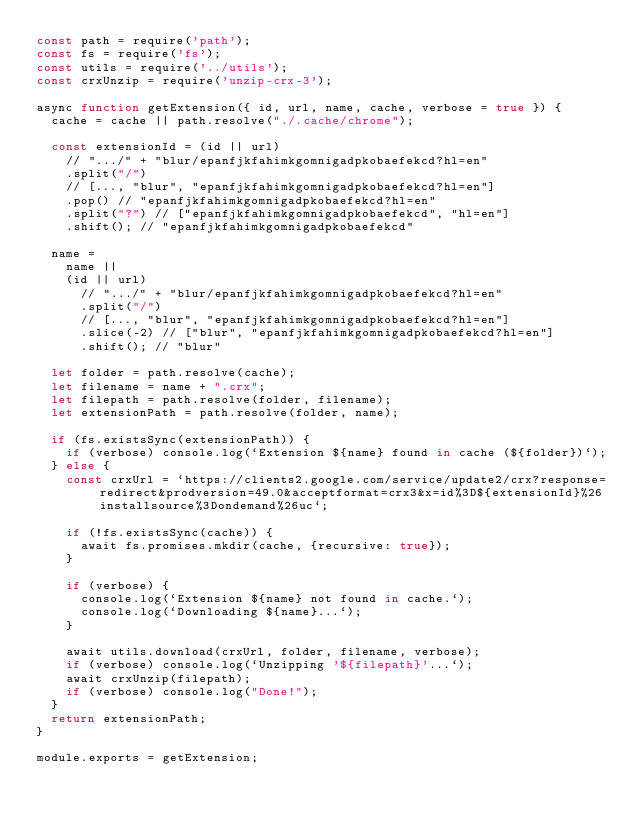Convert code to text. <code><loc_0><loc_0><loc_500><loc_500><_JavaScript_>const path = require('path');
const fs = require('fs');
const utils = require('../utils');
const crxUnzip = require('unzip-crx-3');

async function getExtension({ id, url, name, cache, verbose = true }) {
	cache = cache || path.resolve("./.cache/chrome");

	const extensionId = (id || url)
		// ".../" + "blur/epanfjkfahimkgomnigadpkobaefekcd?hl=en"
		.split("/")
		// [..., "blur", "epanfjkfahimkgomnigadpkobaefekcd?hl=en"]
		.pop() // "epanfjkfahimkgomnigadpkobaefekcd?hl=en"
		.split("?") // ["epanfjkfahimkgomnigadpkobaefekcd", "hl=en"]
		.shift(); // "epanfjkfahimkgomnigadpkobaefekcd"

	name =
		name ||
		(id || url)
			// ".../" + "blur/epanfjkfahimkgomnigadpkobaefekcd?hl=en"
			.split("/")
			// [..., "blur", "epanfjkfahimkgomnigadpkobaefekcd?hl=en"]
			.slice(-2) // ["blur", "epanfjkfahimkgomnigadpkobaefekcd?hl=en"]
			.shift(); // "blur"

	let folder = path.resolve(cache);
	let filename = name + ".crx";
	let filepath = path.resolve(folder, filename);
	let extensionPath = path.resolve(folder, name);

	if (fs.existsSync(extensionPath)) {
		if (verbose) console.log(`Extension ${name} found in cache (${folder})`);
	} else {
		const crxUrl = `https://clients2.google.com/service/update2/crx?response=redirect&prodversion=49.0&acceptformat=crx3&x=id%3D${extensionId}%26installsource%3Dondemand%26uc`;

		if (!fs.existsSync(cache)) {
			await fs.promises.mkdir(cache, {recursive: true});
		}

		if (verbose) {
			console.log(`Extension ${name} not found in cache.`);
			console.log(`Downloading ${name}...`);
		}

		await utils.download(crxUrl, folder, filename, verbose);
		if (verbose) console.log(`Unzipping '${filepath}'...`);
		await crxUnzip(filepath);
		if (verbose) console.log("Done!");
	}
	return extensionPath;
}

module.exports = getExtension;</code> 